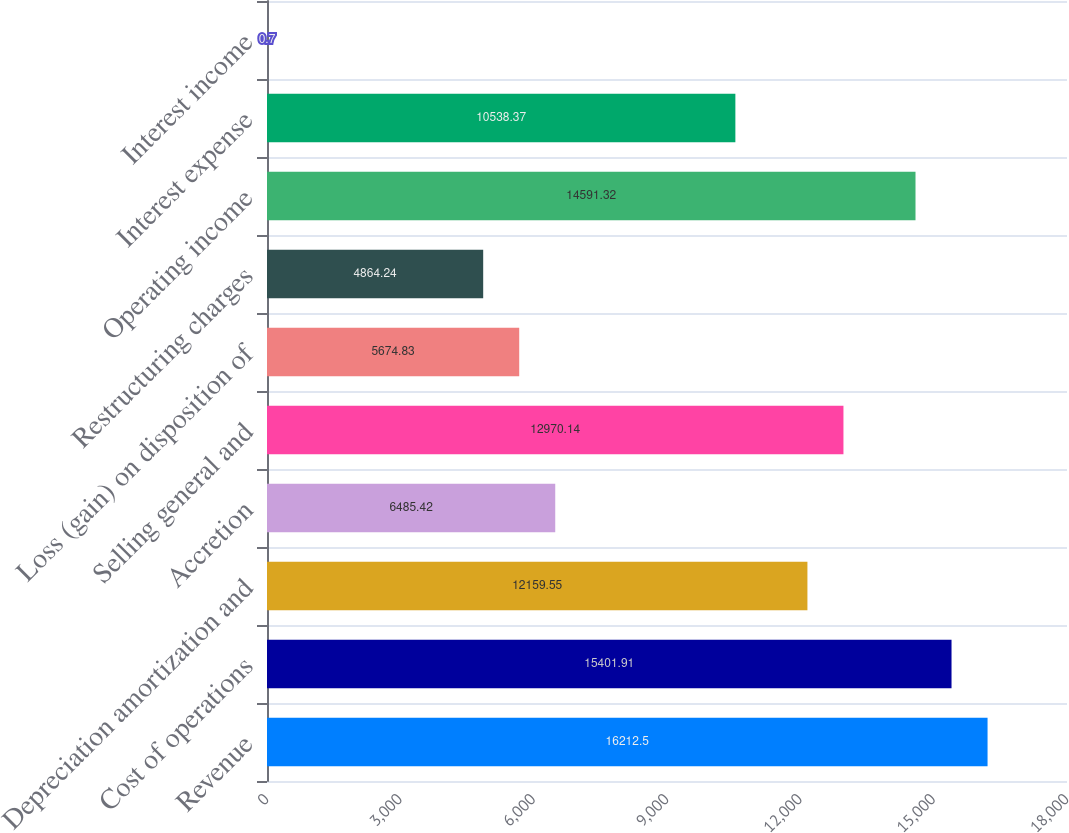Convert chart. <chart><loc_0><loc_0><loc_500><loc_500><bar_chart><fcel>Revenue<fcel>Cost of operations<fcel>Depreciation amortization and<fcel>Accretion<fcel>Selling general and<fcel>Loss (gain) on disposition of<fcel>Restructuring charges<fcel>Operating income<fcel>Interest expense<fcel>Interest income<nl><fcel>16212.5<fcel>15401.9<fcel>12159.5<fcel>6485.42<fcel>12970.1<fcel>5674.83<fcel>4864.24<fcel>14591.3<fcel>10538.4<fcel>0.7<nl></chart> 